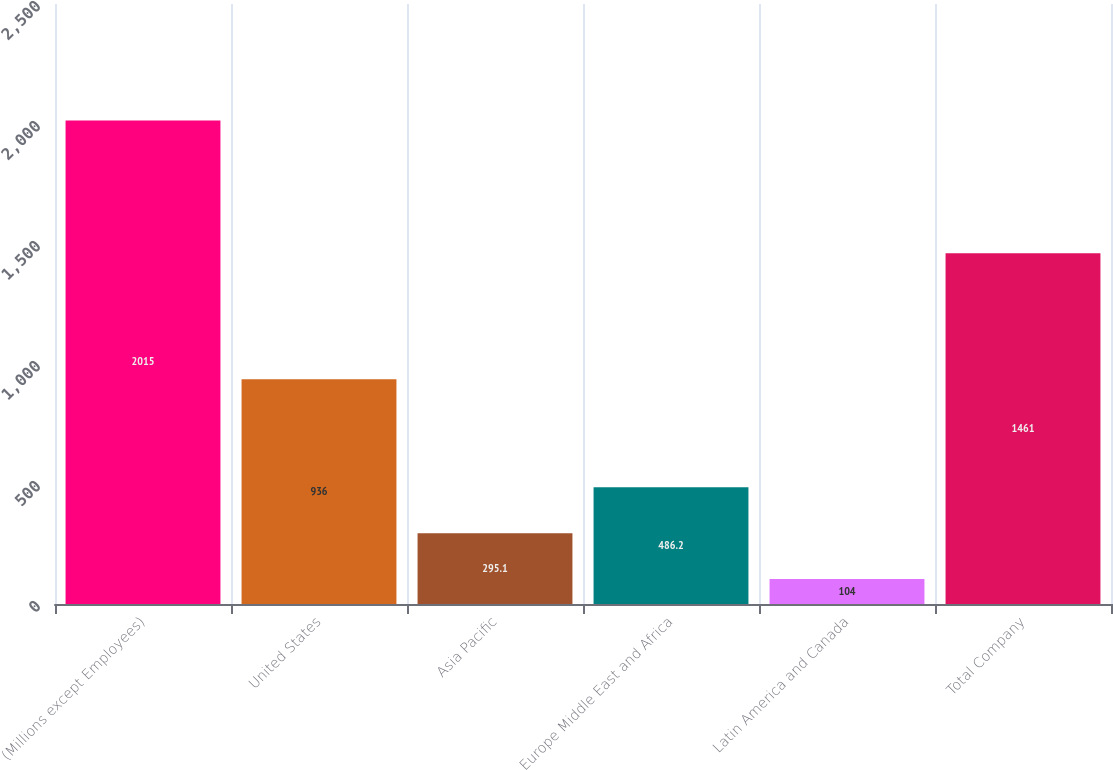Convert chart to OTSL. <chart><loc_0><loc_0><loc_500><loc_500><bar_chart><fcel>(Millions except Employees)<fcel>United States<fcel>Asia Pacific<fcel>Europe Middle East and Africa<fcel>Latin America and Canada<fcel>Total Company<nl><fcel>2015<fcel>936<fcel>295.1<fcel>486.2<fcel>104<fcel>1461<nl></chart> 